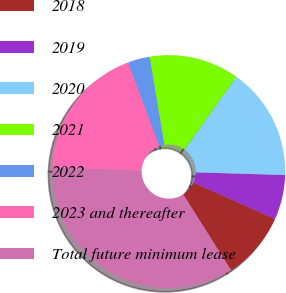<chart> <loc_0><loc_0><loc_500><loc_500><pie_chart><fcel>2018<fcel>2019<fcel>2020<fcel>2021<fcel>2022<fcel>2023 and thereafter<fcel>Total future minimum lease<nl><fcel>9.35%<fcel>6.21%<fcel>15.63%<fcel>12.49%<fcel>3.06%<fcel>18.77%<fcel>34.49%<nl></chart> 